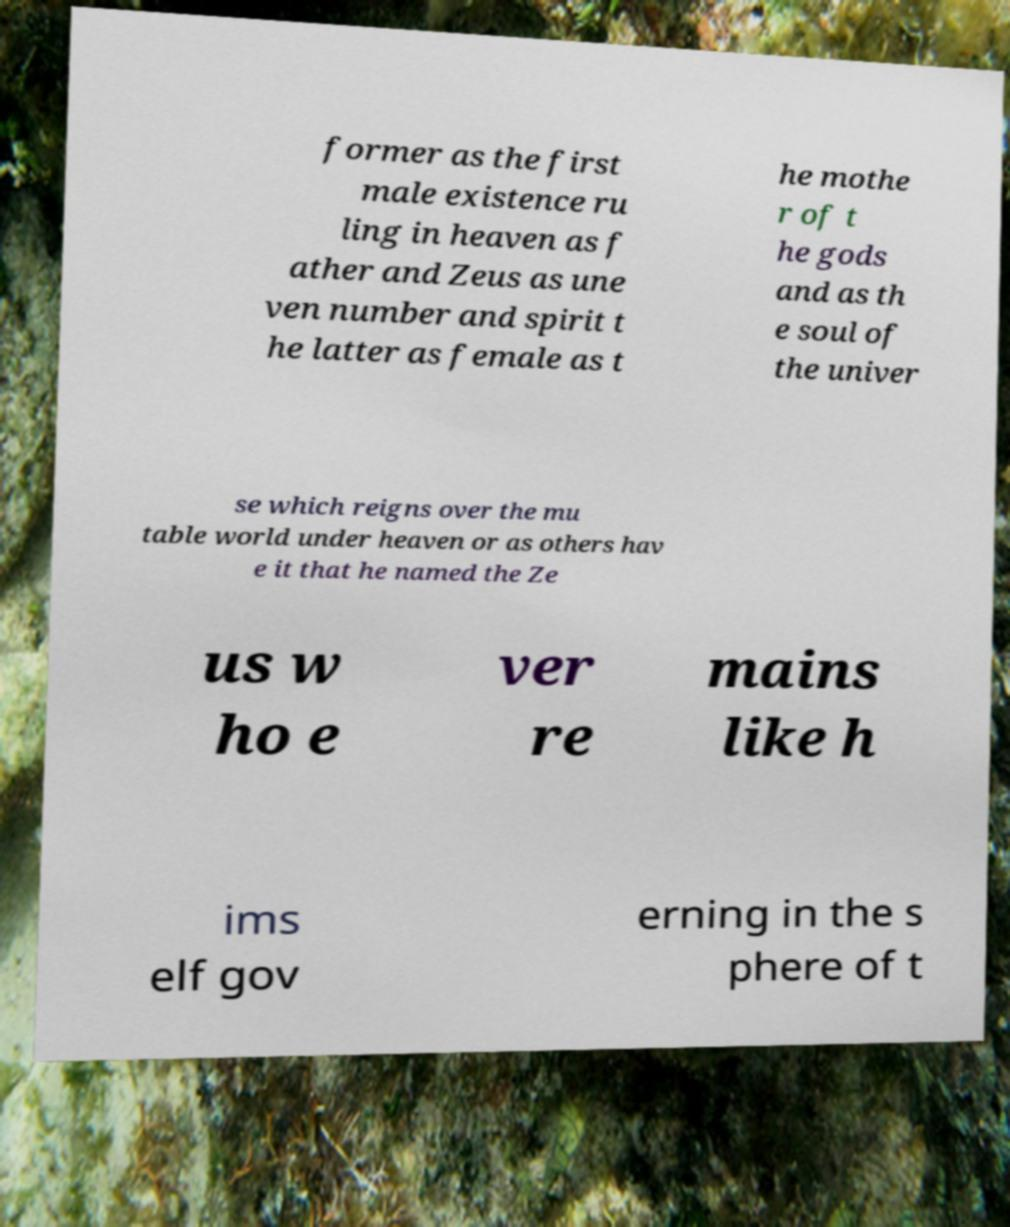For documentation purposes, I need the text within this image transcribed. Could you provide that? former as the first male existence ru ling in heaven as f ather and Zeus as une ven number and spirit t he latter as female as t he mothe r of t he gods and as th e soul of the univer se which reigns over the mu table world under heaven or as others hav e it that he named the Ze us w ho e ver re mains like h ims elf gov erning in the s phere of t 